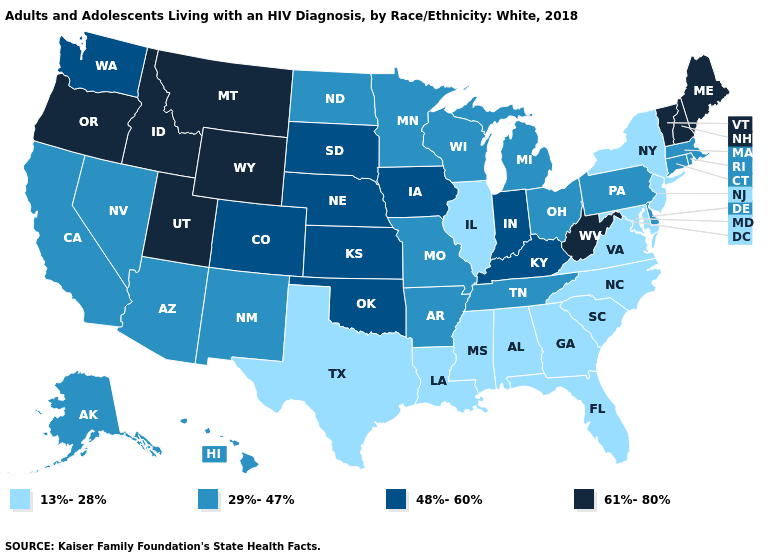What is the lowest value in states that border Vermont?
Short answer required. 13%-28%. What is the value of Florida?
Keep it brief. 13%-28%. What is the value of Oregon?
Keep it brief. 61%-80%. What is the value of Delaware?
Be succinct. 29%-47%. How many symbols are there in the legend?
Answer briefly. 4. What is the highest value in states that border Colorado?
Keep it brief. 61%-80%. What is the highest value in the USA?
Keep it brief. 61%-80%. Which states have the lowest value in the USA?
Short answer required. Alabama, Florida, Georgia, Illinois, Louisiana, Maryland, Mississippi, New Jersey, New York, North Carolina, South Carolina, Texas, Virginia. Name the states that have a value in the range 61%-80%?
Keep it brief. Idaho, Maine, Montana, New Hampshire, Oregon, Utah, Vermont, West Virginia, Wyoming. Which states have the lowest value in the USA?
Concise answer only. Alabama, Florida, Georgia, Illinois, Louisiana, Maryland, Mississippi, New Jersey, New York, North Carolina, South Carolina, Texas, Virginia. Does Maryland have the highest value in the South?
Short answer required. No. What is the value of New York?
Concise answer only. 13%-28%. Name the states that have a value in the range 13%-28%?
Keep it brief. Alabama, Florida, Georgia, Illinois, Louisiana, Maryland, Mississippi, New Jersey, New York, North Carolina, South Carolina, Texas, Virginia. Name the states that have a value in the range 29%-47%?
Short answer required. Alaska, Arizona, Arkansas, California, Connecticut, Delaware, Hawaii, Massachusetts, Michigan, Minnesota, Missouri, Nevada, New Mexico, North Dakota, Ohio, Pennsylvania, Rhode Island, Tennessee, Wisconsin. Is the legend a continuous bar?
Give a very brief answer. No. 